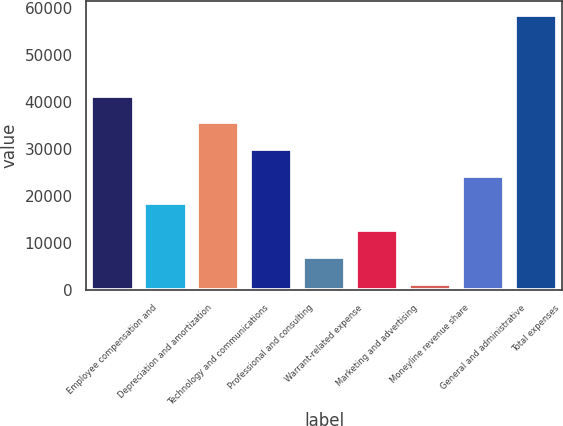Convert chart. <chart><loc_0><loc_0><loc_500><loc_500><bar_chart><fcel>Employee compensation and<fcel>Depreciation and amortization<fcel>Technology and communications<fcel>Professional and consulting<fcel>Warrant-related expense<fcel>Marketing and advertising<fcel>Moneyline revenue share<fcel>General and administrative<fcel>Total expenses<nl><fcel>41308.7<fcel>18412.3<fcel>35584.6<fcel>29860.5<fcel>6964.1<fcel>12688.2<fcel>1240<fcel>24136.4<fcel>58481<nl></chart> 